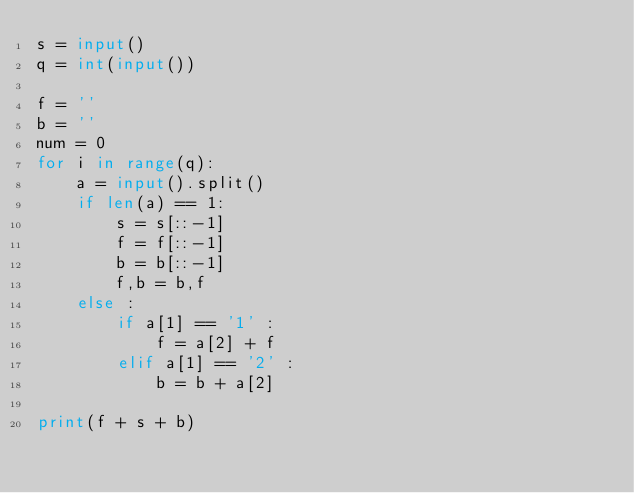<code> <loc_0><loc_0><loc_500><loc_500><_Python_>s = input()
q = int(input())

f = ''
b = ''
num = 0
for i in range(q):
    a = input().split()
    if len(a) == 1:
        s = s[::-1]
        f = f[::-1]
        b = b[::-1]
        f,b = b,f
    else :
        if a[1] == '1' :
            f = a[2] + f
        elif a[1] == '2' :
            b = b + a[2]

print(f + s + b)
</code> 